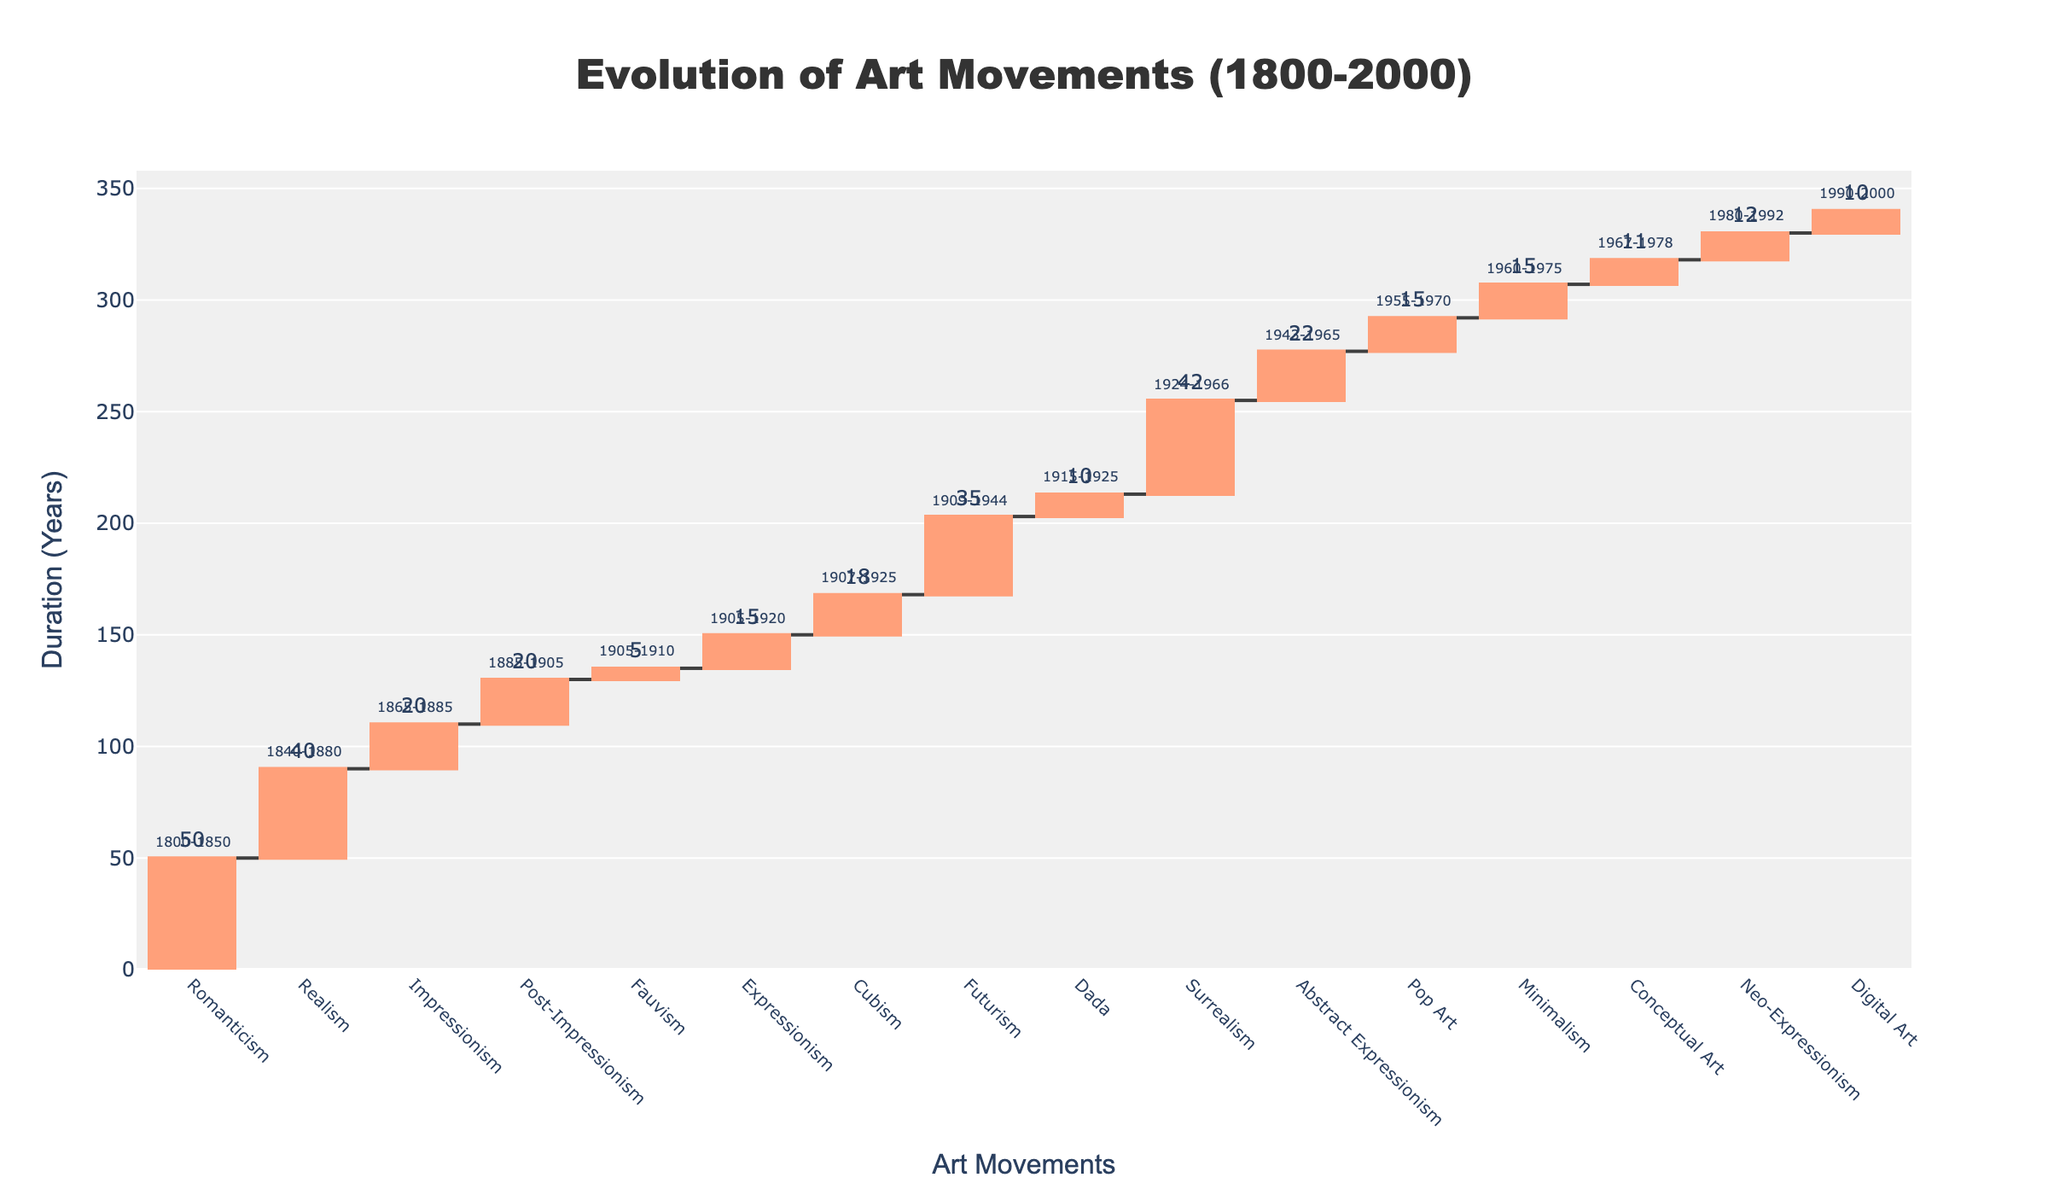What's the title of the figure? The title of the figure is often prominently displayed at the top of the chart to inform the viewer about the overall topic or focus of the visualization. In this figure, the title is located in the top center area.
Answer: Evolution of Art Movements (1800-2000) How many years did the Romanticism movement last? To find the duration of the Romanticism movement, locate the bar labeled "Romanticism" and read the duration value displayed above the bar.
Answer: 50 What is the duration of the longest-lasting art movement in the figure? To determine the longest-lasting art movement, find the bar with the highest duration value. Look for the largest number displayed outside the bar.
Answer: 50 Which art movement started the latest? Identify the art movement with the most recent start year by looking at the annotations displaying the start and end years for each movement. The one with the highest start year is the latest.
Answer: Digital Art How many art movements have a duration less than 20 years? Count the bars with duration values less than 20 displayed next to them. Those values are located outside and above each bar.
Answer: 7 What was the duration of art movements between 1955 and 1978? First, find the movements within the given range: Pop Art (1955-1970), Minimalism (1960-1975), and Conceptual Art (1967-1978). Then, sum their durations (Pop Art: 15, Minimalism: 15, Conceptual Art: 11).
Answer: 41 Which art movements lasted exactly 10 years? Determine the art movements with a duration value of 10 by locating the bar with "10" displayed outside it.
Answer: Dada and Digital Art Which art movement ended in 1965? Locate the movement with the annotation "1965" in its end year. Identify the corresponding bar labeled with the movement name.
Answer: Abstract Expressionism What is the difference in duration between Realism and Impressionism? Find the duration of both movements: Realism (40 years) and Impressionism (20 years). Subtract Impressionism's duration from Realism's duration (40 - 20).
Answer: 20 What is the cumulative duration up to and including Cubism? Compute the cumulative duration by summing the durations from Romanticism to Cubism (50 + 40 + 20 + 20 + 5 + 15 + 18). The cumulative value is displayed at Cubism’s endpoint.
Answer: 168 